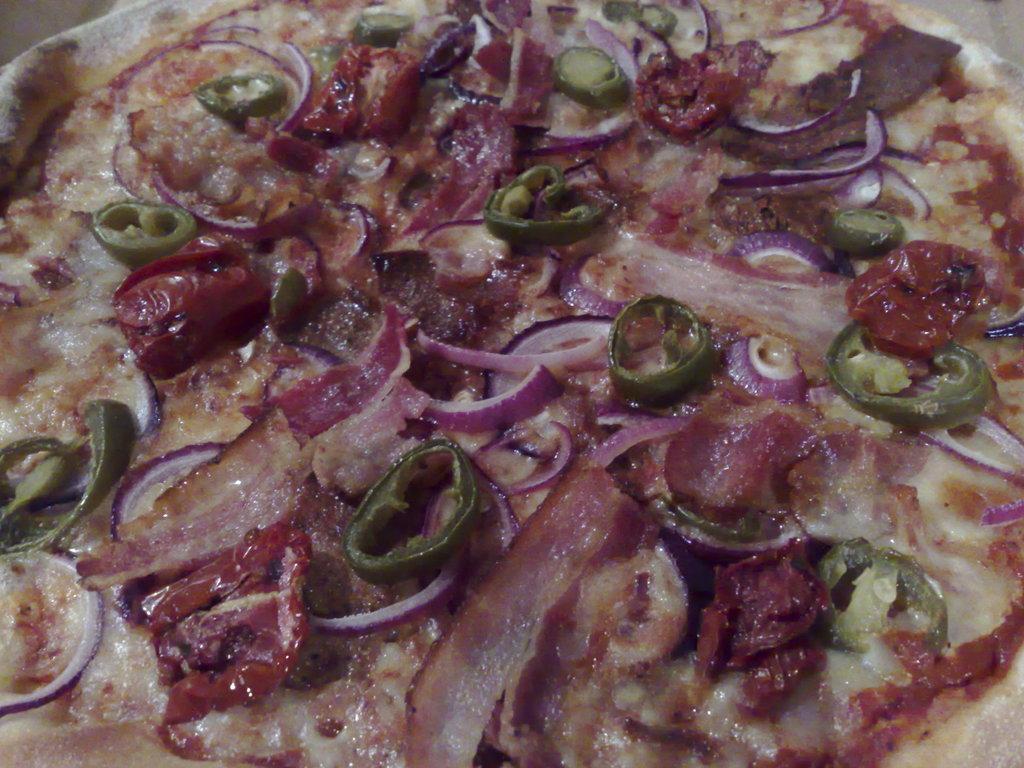How would you summarize this image in a sentence or two? In this image we can see a food item, on that there are some onion, and green chili slices. 